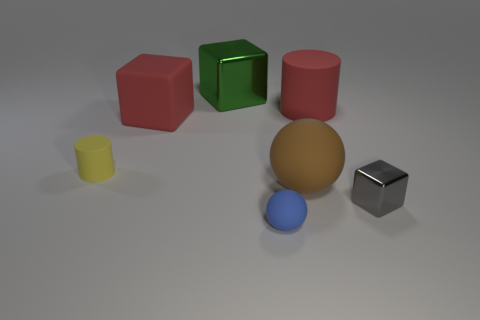Add 3 blue objects. How many objects exist? 10 Subtract all cylinders. How many objects are left? 5 Subtract all tiny matte balls. Subtract all gray blocks. How many objects are left? 5 Add 4 large metal blocks. How many large metal blocks are left? 5 Add 1 small yellow metallic things. How many small yellow metallic things exist? 1 Subtract 0 purple cubes. How many objects are left? 7 